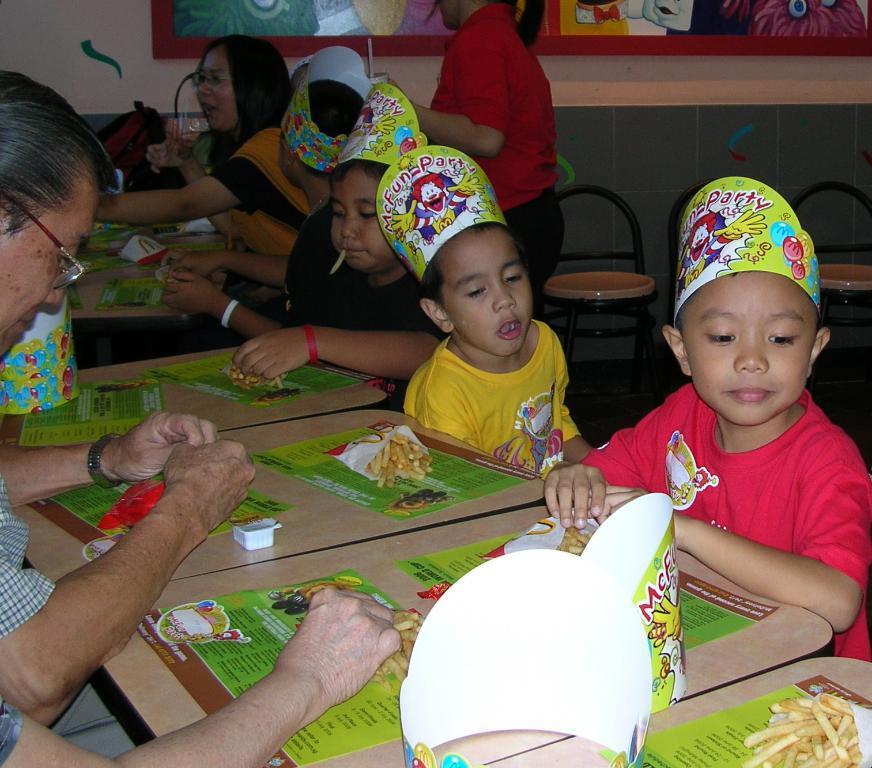In one or two sentences, can you explain what this image depicts? In this picture we can see some food items in the packets, menu cards and other objects are visible on the tables. We can see a few people and some kids are sitting. A person is standing. There are a few chairs. We can see a frame on the wall. 